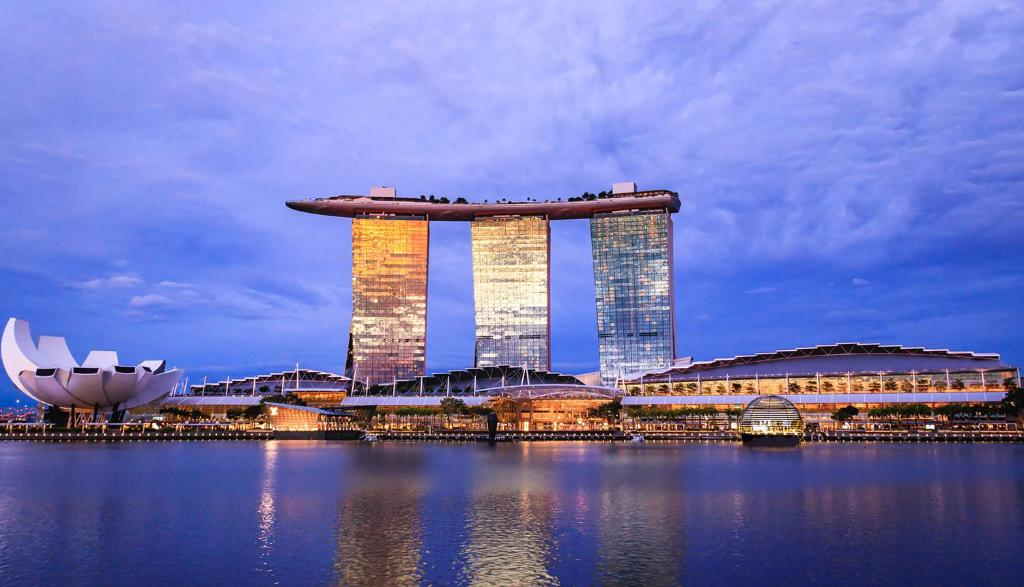If this area was transformed into a fictional setting for a movie, what genre would fit best and why? This breathtaking area could serve as a stunning backdrop for a sci-fi movie. The futuristic architecture of Marina Bay Sands and the ArtScience Museum, coupled with the vibrant city lights and tranquil waters, creates an otherworldly atmosphere. Imagine a story where advanced civilizations meet, merging art, science, and technology in this sophisticated urban landscape. The serene infinity pool could be a place of mystic power, while the SkyPark serves as a landing pad for sleek, advanced spacecraft.  Envision an epic adventure scenario. In an epic adventure scenario, Marina Bay Sands could be the headquarters of a global organization dedicated to preserving humanity’s history and culture. An ancient artifact, hidden within the ArtScience Museum, is the key to unlocking incredible powers. The hero races against time, navigating through the luxurious hotel rooms, rooftop garden, and even the vast infinity pool, to prevent a nefarious group from obtaining the artifact and altering human history. Explosions light up the skyline as the final showdown unfolds on the SkyPark, amidst the serene pools and lush greenery. 